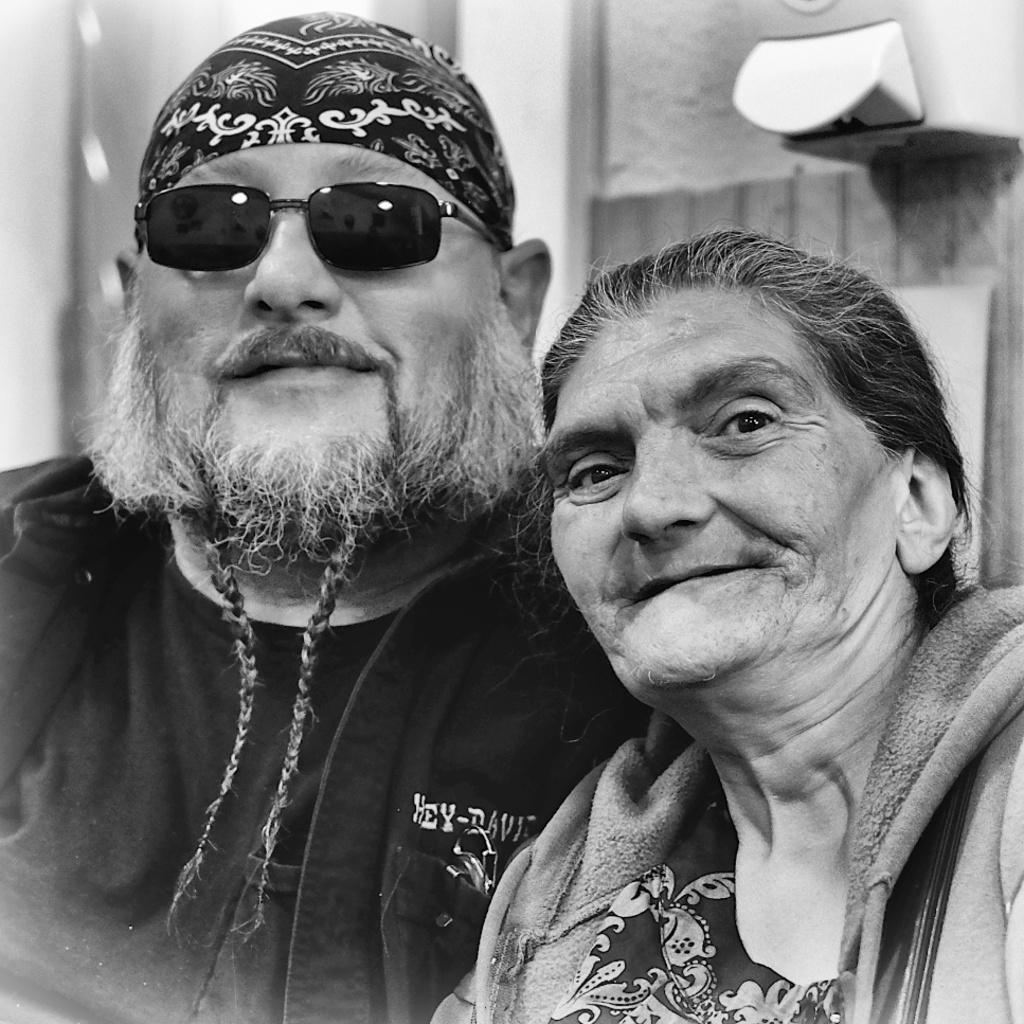How many people are in the image? There are two persons in the image. What are the people wearing? Both persons are wearing clothes. Where is the person on the left side of the image located? The person on the left side is on the left side of the image. What accessory is the person on the left side wearing? The person on the left side is wearing sunglasses. What type of sweater is the mother wearing in the image? There is no mention of a mother or a sweater in the image. The image only features two persons, and no clothing items are specified beyond the fact that they are wearing clothes. 